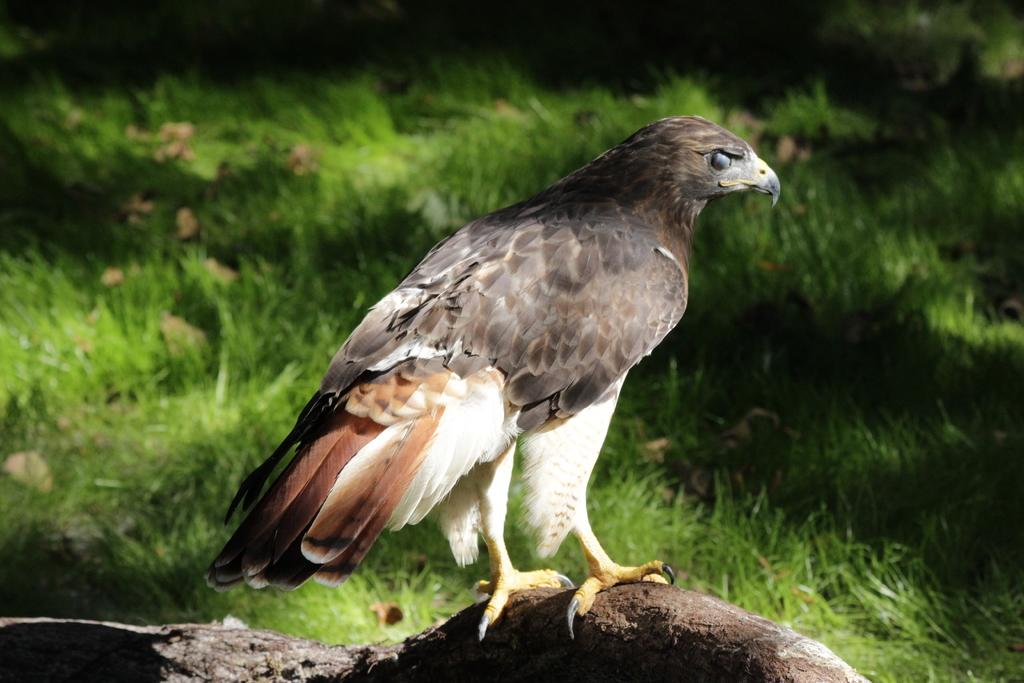What type of animal can be seen in the image? There is a bird in the image. Where is the bird located? The bird is on a tree branch. What type of vegetation is visible in the background of the image? There is grass visible in the background of the image. What type of creature is playing a musical instrument in the image? There is no creature playing a musical instrument in the image; it only features a bird on a tree branch. Can you hear the bird making any sounds in the image? The image is silent, so we cannot hear any sounds made by the bird. 